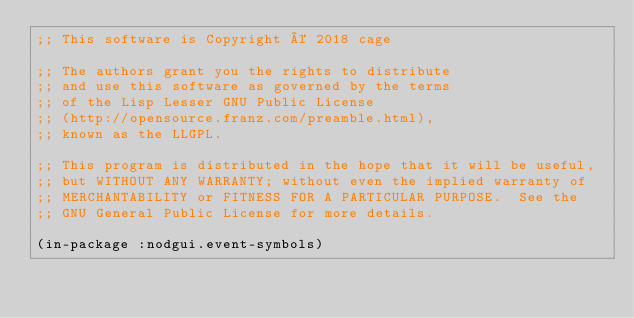<code> <loc_0><loc_0><loc_500><loc_500><_Lisp_>;; This software is Copyright © 2018 cage

;; The authors grant you the rights to distribute
;; and use this software as governed by the terms
;; of the Lisp Lesser GNU Public License
;; (http://opensource.franz.com/preamble.html),
;; known as the LLGPL.

;; This program is distributed in the hope that it will be useful,
;; but WITHOUT ANY WARRANTY; without even the implied warranty of
;; MERCHANTABILITY or FITNESS FOR A PARTICULAR PURPOSE.  See the
;; GNU General Public License for more details.

(in-package :nodgui.event-symbols)
</code> 